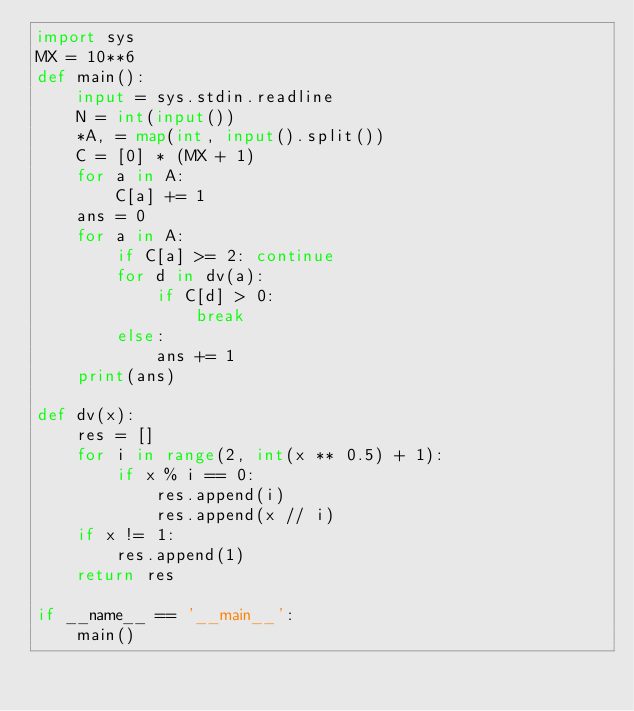Convert code to text. <code><loc_0><loc_0><loc_500><loc_500><_Python_>import sys
MX = 10**6
def main():
    input = sys.stdin.readline
    N = int(input())
    *A, = map(int, input().split())
    C = [0] * (MX + 1)
    for a in A:
        C[a] += 1
    ans = 0
    for a in A:
        if C[a] >= 2: continue
        for d in dv(a):
            if C[d] > 0:
                break
        else:
            ans += 1
    print(ans)

def dv(x):
    res = []
    for i in range(2, int(x ** 0.5) + 1):
        if x % i == 0:
            res.append(i)
            res.append(x // i)
    if x != 1:
        res.append(1)
    return res

if __name__ == '__main__':
    main()
</code> 